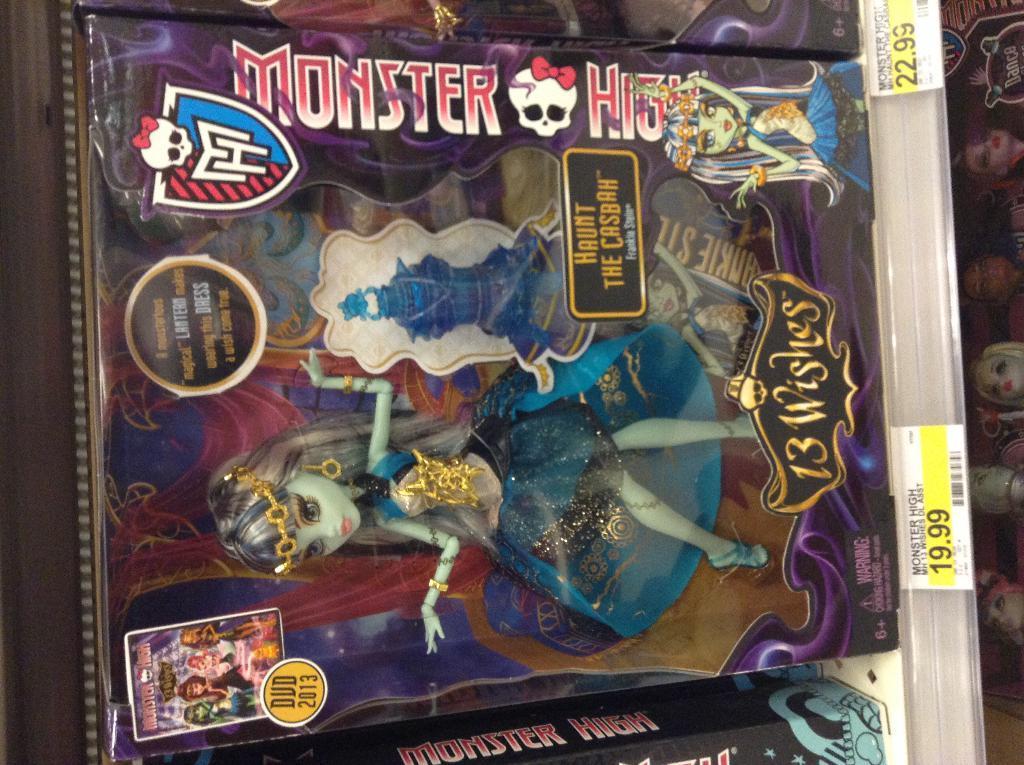In one or two sentences, can you explain what this image depicts? In this picture we can see a barbie doll packed in a box. We can see some labels and stickers. On the right side of the picture we can see dolls. 